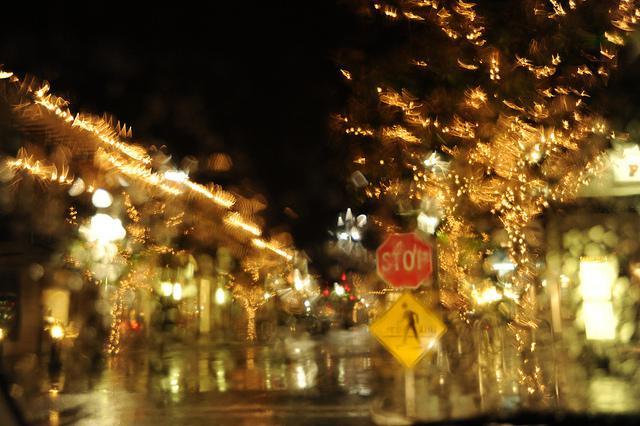What season is this?
Concise answer only. Winter. What two traffic signs are present?
Short answer required. Stop sign and pedestrian crossing sign beneath it. Is the photo blurry?
Write a very short answer. Yes. 